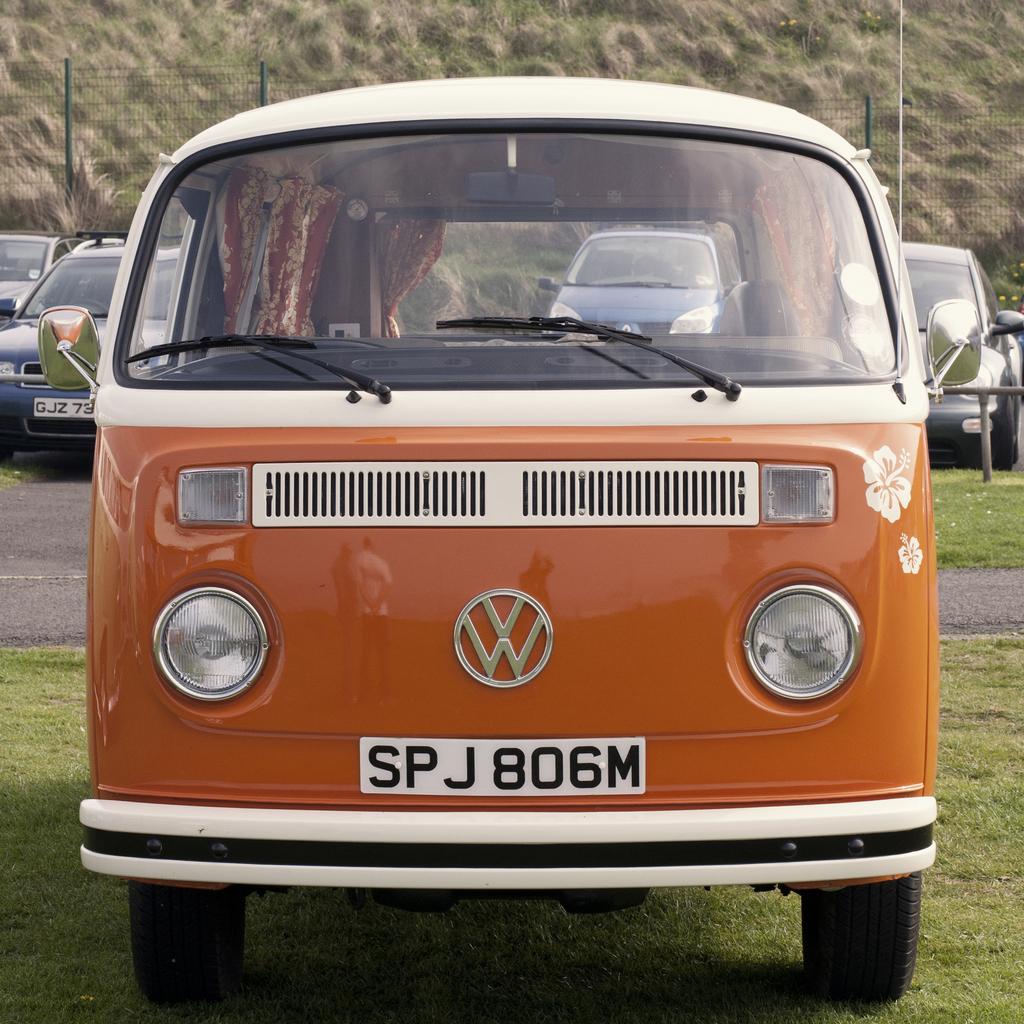What is on the license plate?
Keep it short and to the point. Spj806m. Which 3 numbers are on the licence plate?
Offer a very short reply. 806. 